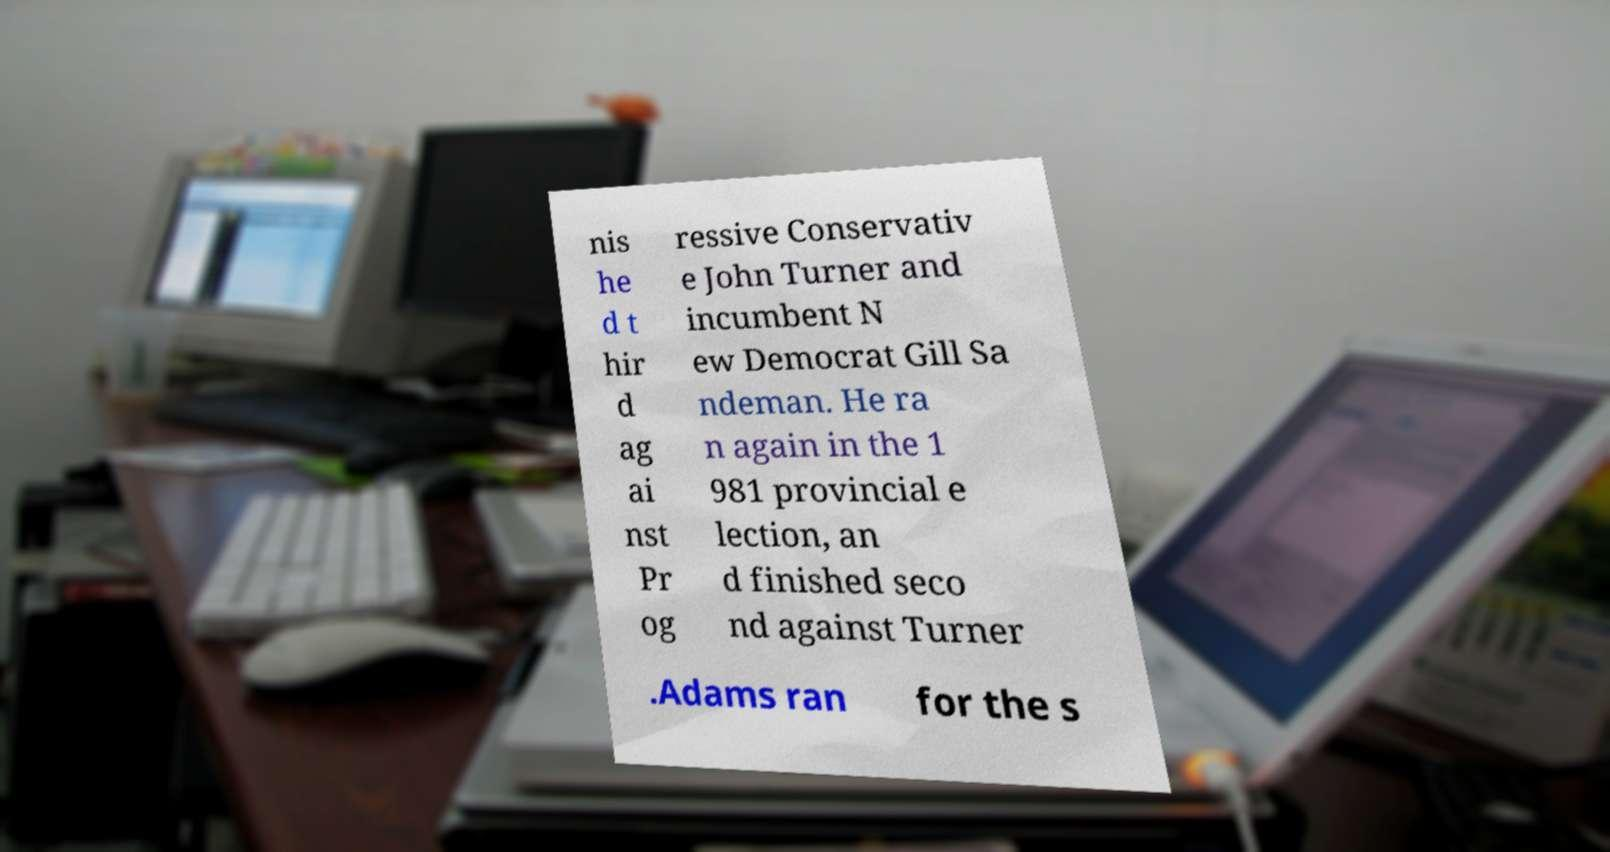Please identify and transcribe the text found in this image. nis he d t hir d ag ai nst Pr og ressive Conservativ e John Turner and incumbent N ew Democrat Gill Sa ndeman. He ra n again in the 1 981 provincial e lection, an d finished seco nd against Turner .Adams ran for the s 